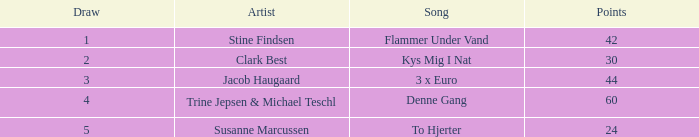What draw has over 44 points and holds a place higher than 1? None. 